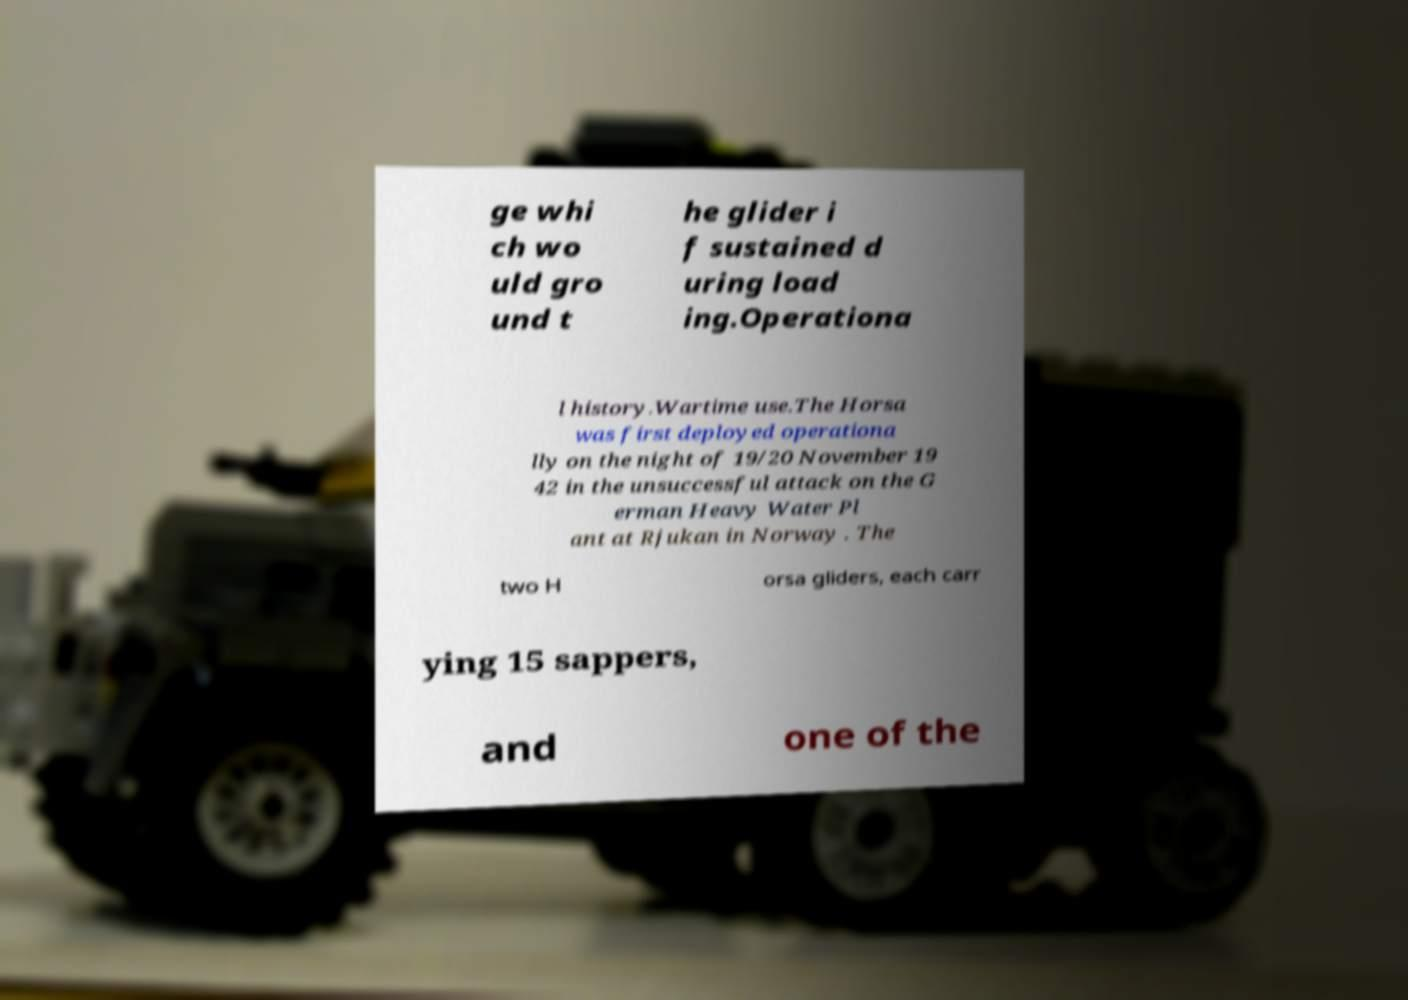Can you read and provide the text displayed in the image?This photo seems to have some interesting text. Can you extract and type it out for me? ge whi ch wo uld gro und t he glider i f sustained d uring load ing.Operationa l history.Wartime use.The Horsa was first deployed operationa lly on the night of 19/20 November 19 42 in the unsuccessful attack on the G erman Heavy Water Pl ant at Rjukan in Norway . The two H orsa gliders, each carr ying 15 sappers, and one of the 